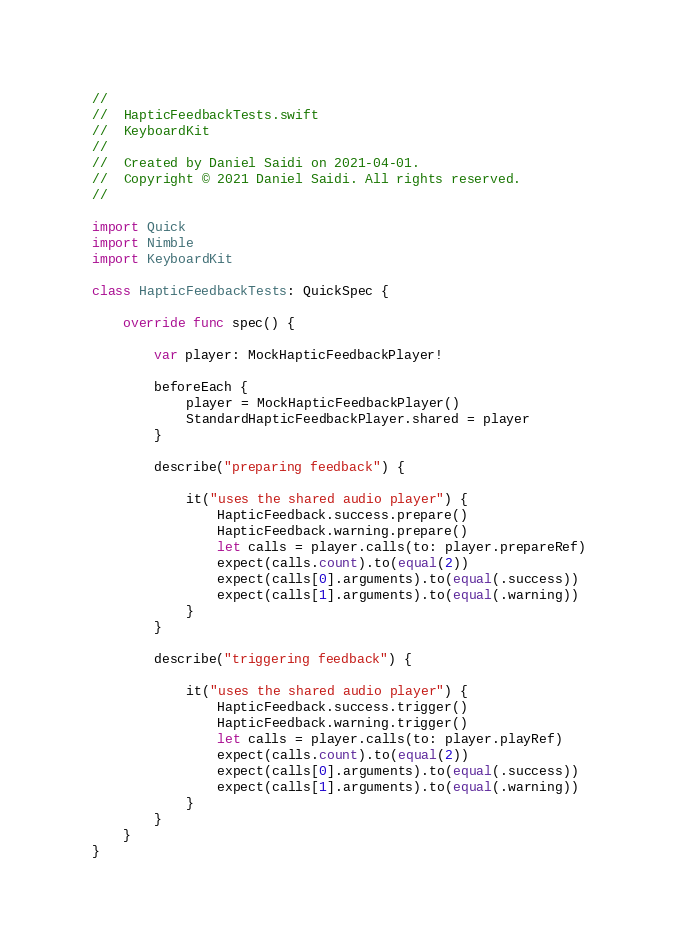Convert code to text. <code><loc_0><loc_0><loc_500><loc_500><_Swift_>//
//  HapticFeedbackTests.swift
//  KeyboardKit
//
//  Created by Daniel Saidi on 2021-04-01.
//  Copyright © 2021 Daniel Saidi. All rights reserved.
//

import Quick
import Nimble
import KeyboardKit

class HapticFeedbackTests: QuickSpec {
    
    override func spec() {
        
        var player: MockHapticFeedbackPlayer!
        
        beforeEach {
            player = MockHapticFeedbackPlayer()
            StandardHapticFeedbackPlayer.shared = player
        }
        
        describe("preparing feedback") {
            
            it("uses the shared audio player") {
                HapticFeedback.success.prepare()
                HapticFeedback.warning.prepare()
                let calls = player.calls(to: player.prepareRef)
                expect(calls.count).to(equal(2))
                expect(calls[0].arguments).to(equal(.success))
                expect(calls[1].arguments).to(equal(.warning))
            }
        }
        
        describe("triggering feedback") {
            
            it("uses the shared audio player") {
                HapticFeedback.success.trigger()
                HapticFeedback.warning.trigger()
                let calls = player.calls(to: player.playRef)
                expect(calls.count).to(equal(2))
                expect(calls[0].arguments).to(equal(.success))
                expect(calls[1].arguments).to(equal(.warning))
            }
        }
    }
}
</code> 